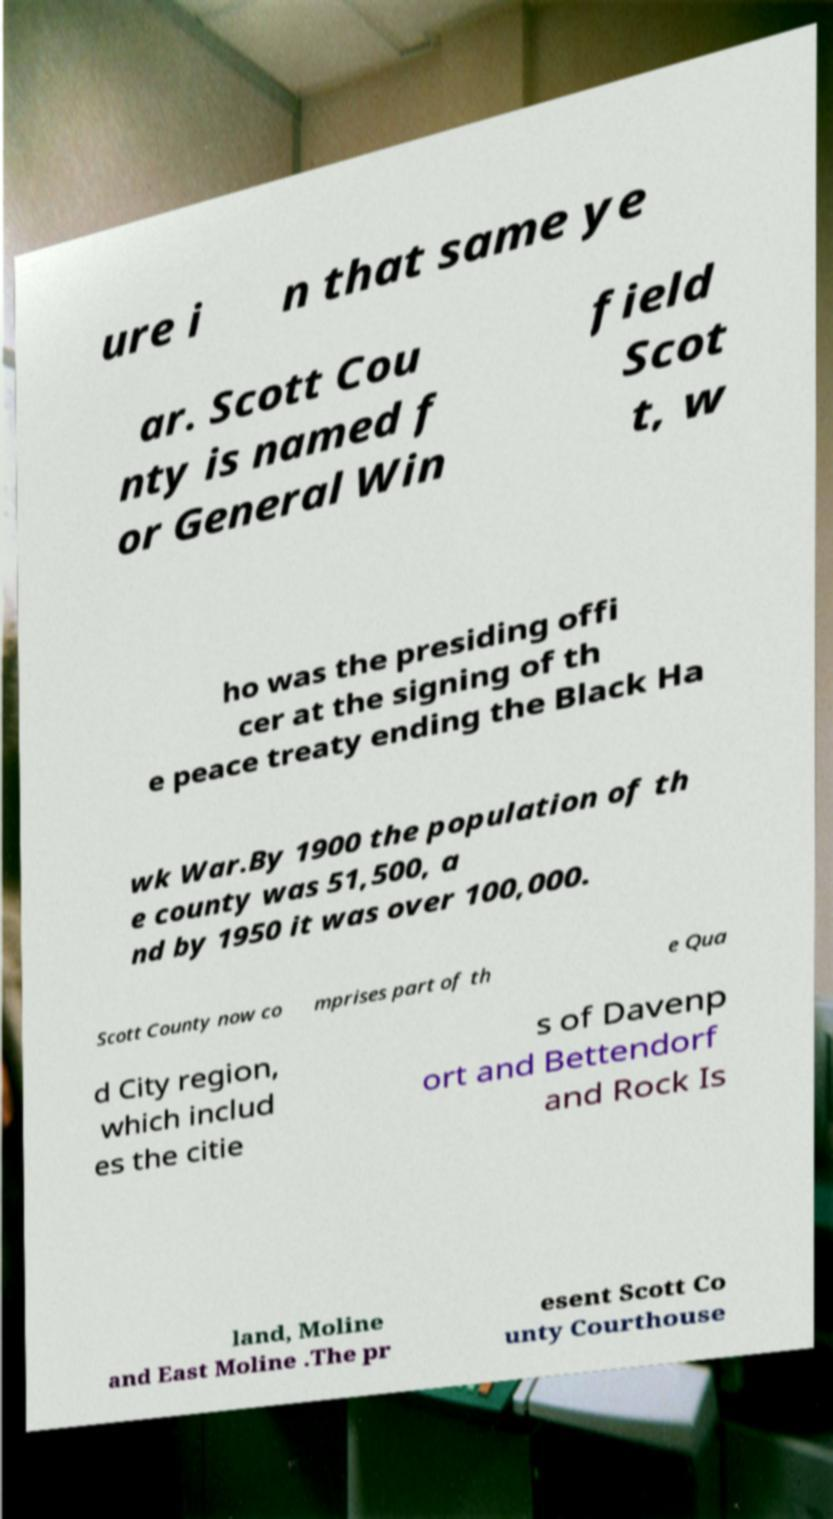There's text embedded in this image that I need extracted. Can you transcribe it verbatim? ure i n that same ye ar. Scott Cou nty is named f or General Win field Scot t, w ho was the presiding offi cer at the signing of th e peace treaty ending the Black Ha wk War.By 1900 the population of th e county was 51,500, a nd by 1950 it was over 100,000. Scott County now co mprises part of th e Qua d City region, which includ es the citie s of Davenp ort and Bettendorf and Rock Is land, Moline and East Moline .The pr esent Scott Co unty Courthouse 